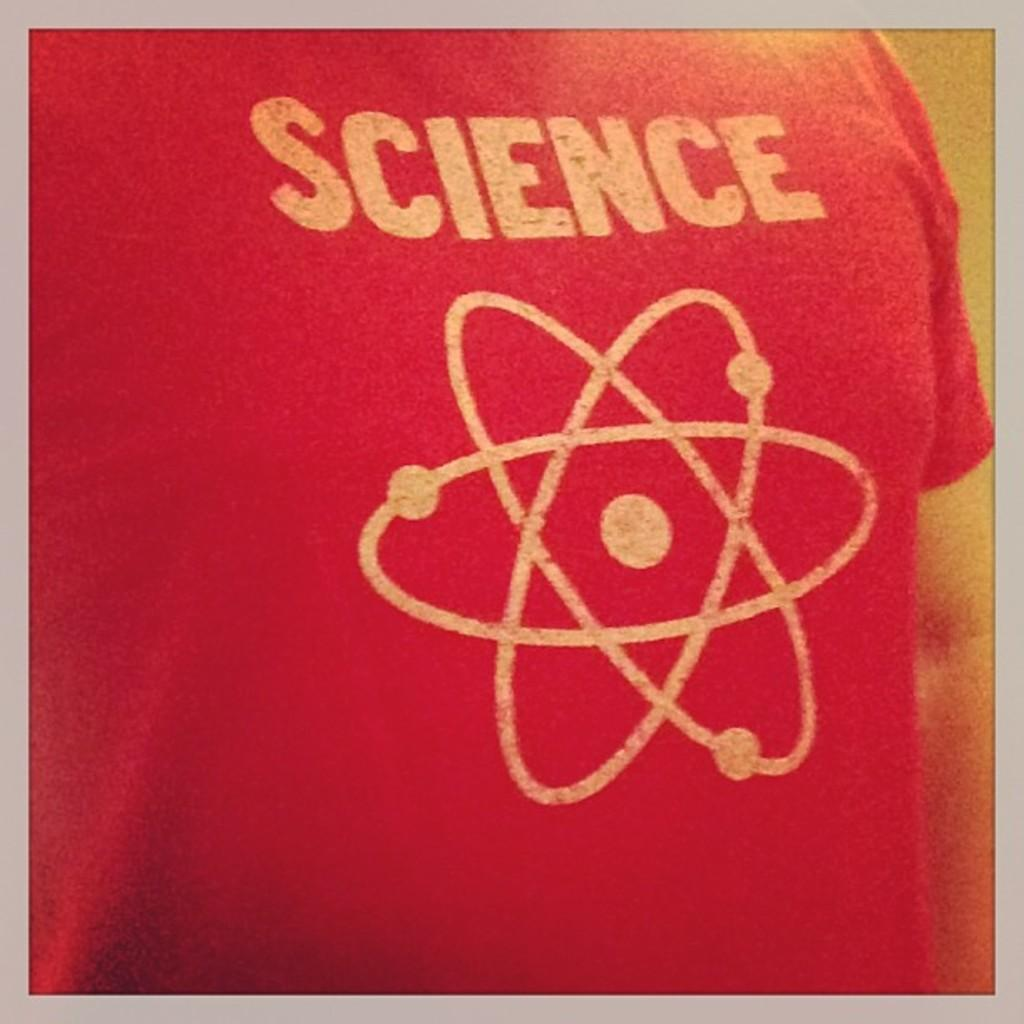Provide a one-sentence caption for the provided image. A person wearing a red t shirt with "Science" printed over a Spirograph design. 